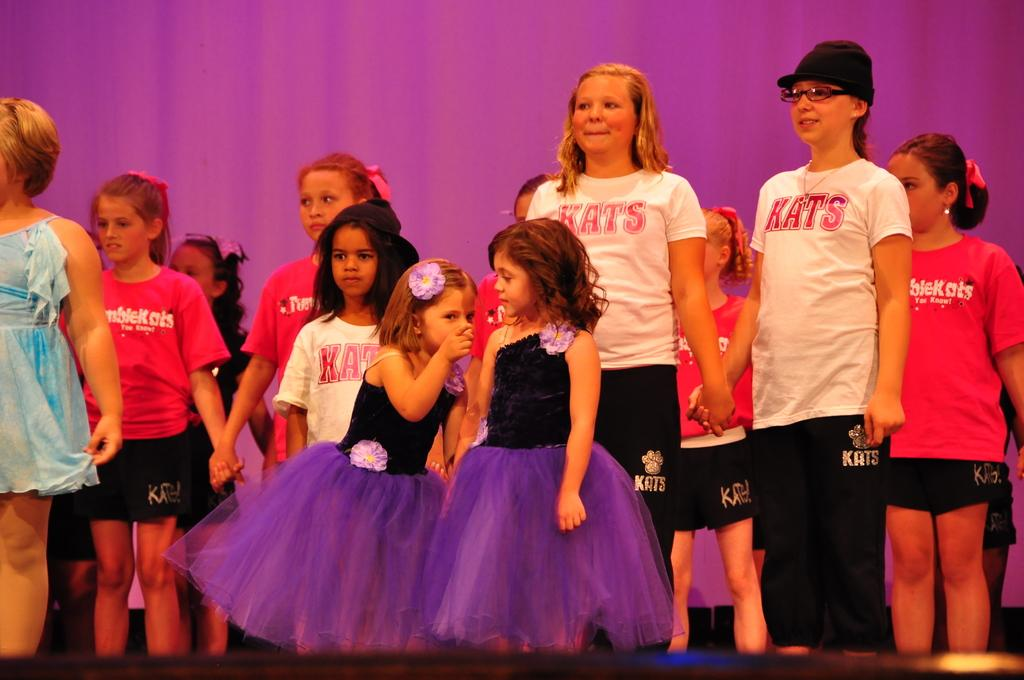What is the main subject of the image? The main subject of the image is a group of people. What are the people in the image doing? The people are standing. How can we differentiate the people in the image? The people are wearing different color dresses. What is the color of the background in the image? The background of the image is in purple color. Can you tell me how many beetles are crawling on the people's dresses in the image? There are no beetles present in the image; the people are wearing different color dresses. What type of grip does the bulb have in the image? There is no bulb present in the image; the main subject is a group of people standing in different color dresses with a purple background. 